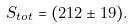Convert formula to latex. <formula><loc_0><loc_0><loc_500><loc_500>S _ { t o t } = ( 2 1 2 \pm 1 9 ) .</formula> 